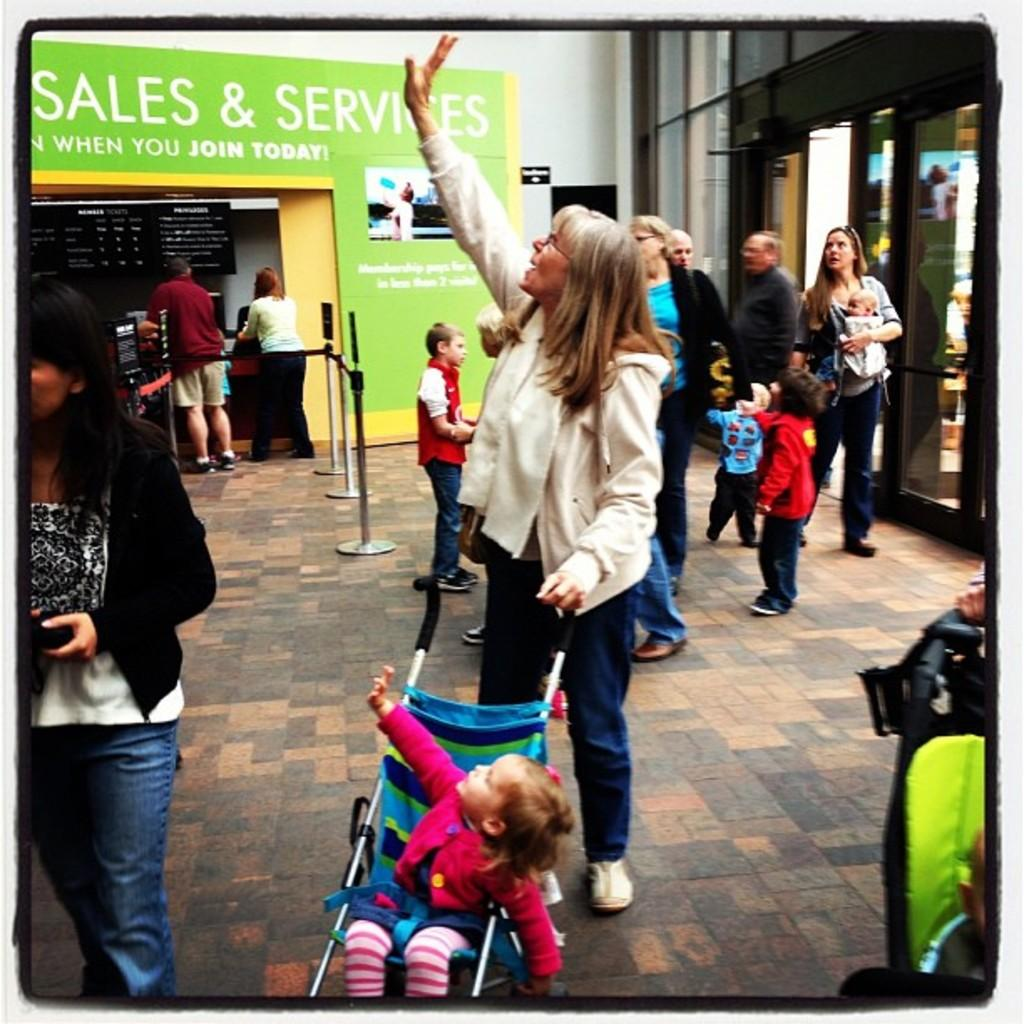What is happening with the people in the image? There are people on the floor in the image. Can you describe the baby in the image? There is a baby sitting in a stroller in the image. What is the gender distribution of the people in the image? There are men and women in the image. What type of property is being stolen in the image? There is no indication of any property being stolen in the image. Can you describe the boy in the image? There is no boy present in the image; only a baby in a stroller is mentioned. 